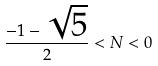Convert formula to latex. <formula><loc_0><loc_0><loc_500><loc_500>\frac { - 1 - \sqrt { 5 } } { 2 } < N < 0</formula> 